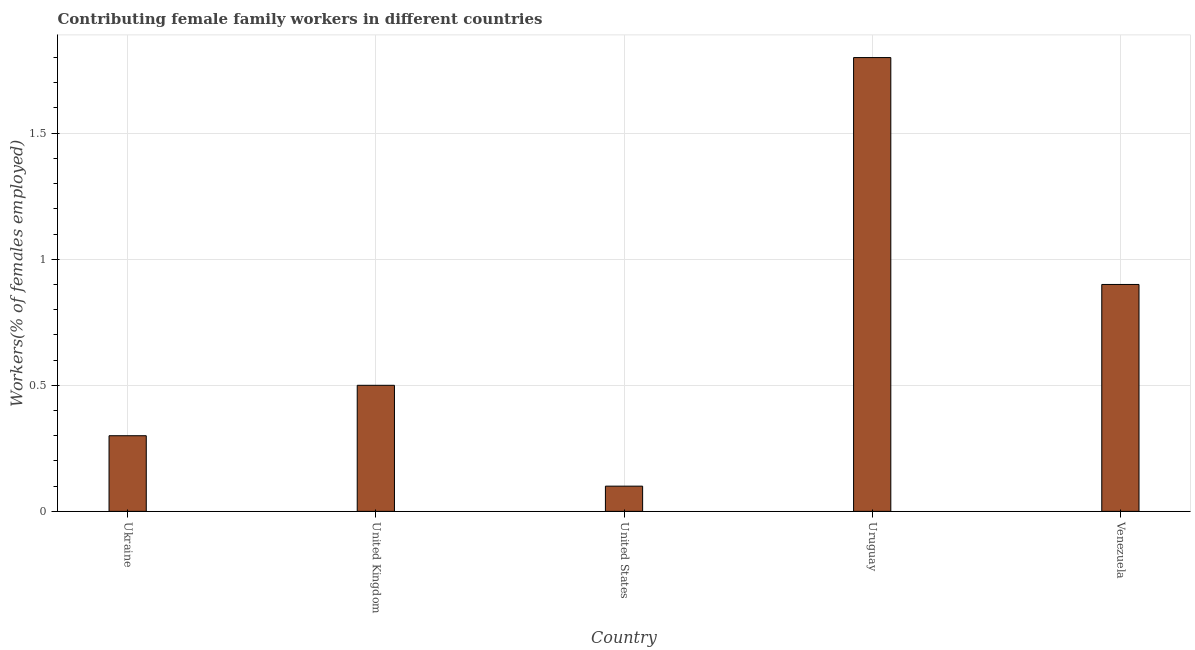Does the graph contain any zero values?
Provide a short and direct response. No. Does the graph contain grids?
Keep it short and to the point. Yes. What is the title of the graph?
Give a very brief answer. Contributing female family workers in different countries. What is the label or title of the X-axis?
Give a very brief answer. Country. What is the label or title of the Y-axis?
Your response must be concise. Workers(% of females employed). What is the contributing female family workers in Ukraine?
Offer a terse response. 0.3. Across all countries, what is the maximum contributing female family workers?
Provide a short and direct response. 1.8. Across all countries, what is the minimum contributing female family workers?
Your answer should be very brief. 0.1. In which country was the contributing female family workers maximum?
Make the answer very short. Uruguay. In which country was the contributing female family workers minimum?
Provide a short and direct response. United States. What is the sum of the contributing female family workers?
Ensure brevity in your answer.  3.6. What is the difference between the contributing female family workers in United States and Venezuela?
Your response must be concise. -0.8. What is the average contributing female family workers per country?
Give a very brief answer. 0.72. What is the ratio of the contributing female family workers in United Kingdom to that in United States?
Give a very brief answer. 5. Is the contributing female family workers in United States less than that in Uruguay?
Your answer should be very brief. Yes. Is the difference between the contributing female family workers in United Kingdom and Uruguay greater than the difference between any two countries?
Ensure brevity in your answer.  No. Is the sum of the contributing female family workers in United Kingdom and Uruguay greater than the maximum contributing female family workers across all countries?
Offer a very short reply. Yes. What is the difference between the highest and the lowest contributing female family workers?
Give a very brief answer. 1.7. In how many countries, is the contributing female family workers greater than the average contributing female family workers taken over all countries?
Provide a short and direct response. 2. What is the difference between two consecutive major ticks on the Y-axis?
Your answer should be compact. 0.5. Are the values on the major ticks of Y-axis written in scientific E-notation?
Give a very brief answer. No. What is the Workers(% of females employed) of Ukraine?
Provide a short and direct response. 0.3. What is the Workers(% of females employed) of United Kingdom?
Keep it short and to the point. 0.5. What is the Workers(% of females employed) in United States?
Your answer should be very brief. 0.1. What is the Workers(% of females employed) of Uruguay?
Your response must be concise. 1.8. What is the Workers(% of females employed) of Venezuela?
Offer a very short reply. 0.9. What is the difference between the Workers(% of females employed) in Ukraine and United Kingdom?
Offer a very short reply. -0.2. What is the difference between the Workers(% of females employed) in Ukraine and Venezuela?
Your answer should be very brief. -0.6. What is the difference between the Workers(% of females employed) in United Kingdom and Uruguay?
Offer a very short reply. -1.3. What is the difference between the Workers(% of females employed) in United Kingdom and Venezuela?
Ensure brevity in your answer.  -0.4. What is the difference between the Workers(% of females employed) in United States and Uruguay?
Offer a very short reply. -1.7. What is the ratio of the Workers(% of females employed) in Ukraine to that in United Kingdom?
Keep it short and to the point. 0.6. What is the ratio of the Workers(% of females employed) in Ukraine to that in Uruguay?
Keep it short and to the point. 0.17. What is the ratio of the Workers(% of females employed) in Ukraine to that in Venezuela?
Offer a very short reply. 0.33. What is the ratio of the Workers(% of females employed) in United Kingdom to that in United States?
Keep it short and to the point. 5. What is the ratio of the Workers(% of females employed) in United Kingdom to that in Uruguay?
Offer a very short reply. 0.28. What is the ratio of the Workers(% of females employed) in United Kingdom to that in Venezuela?
Your answer should be compact. 0.56. What is the ratio of the Workers(% of females employed) in United States to that in Uruguay?
Your answer should be compact. 0.06. What is the ratio of the Workers(% of females employed) in United States to that in Venezuela?
Provide a succinct answer. 0.11. What is the ratio of the Workers(% of females employed) in Uruguay to that in Venezuela?
Make the answer very short. 2. 